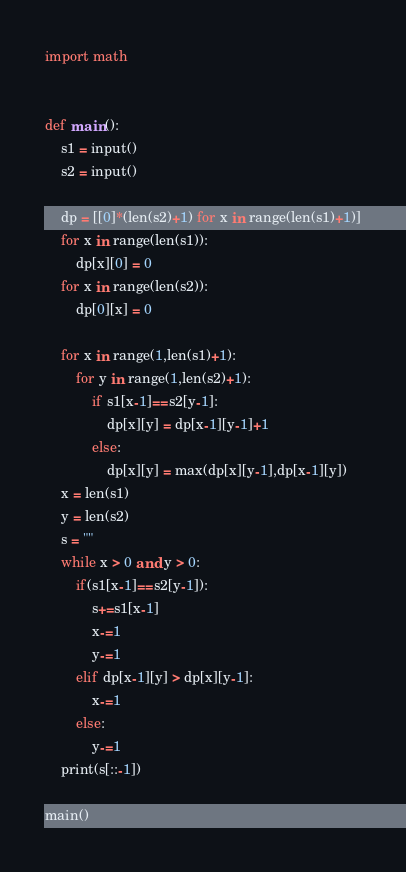<code> <loc_0><loc_0><loc_500><loc_500><_Python_>import math


def main():
    s1 = input()   
    s2 = input()
    
    dp = [[0]*(len(s2)+1) for x in range(len(s1)+1)]
    for x in range(len(s1)):
        dp[x][0] = 0
    for x in range(len(s2)):
        dp[0][x] = 0
    
    for x in range(1,len(s1)+1):
        for y in range(1,len(s2)+1):
            if s1[x-1]==s2[y-1]:
                dp[x][y] = dp[x-1][y-1]+1
            else:
                dp[x][y] = max(dp[x][y-1],dp[x-1][y])
    x = len(s1)
    y = len(s2)
    s = ""
    while x > 0 and y > 0:
        if(s1[x-1]==s2[y-1]):
            s+=s1[x-1]
            x-=1
            y-=1
        elif dp[x-1][y] > dp[x][y-1]:
            x-=1
        else:
            y-=1
    print(s[::-1])
    
main()</code> 